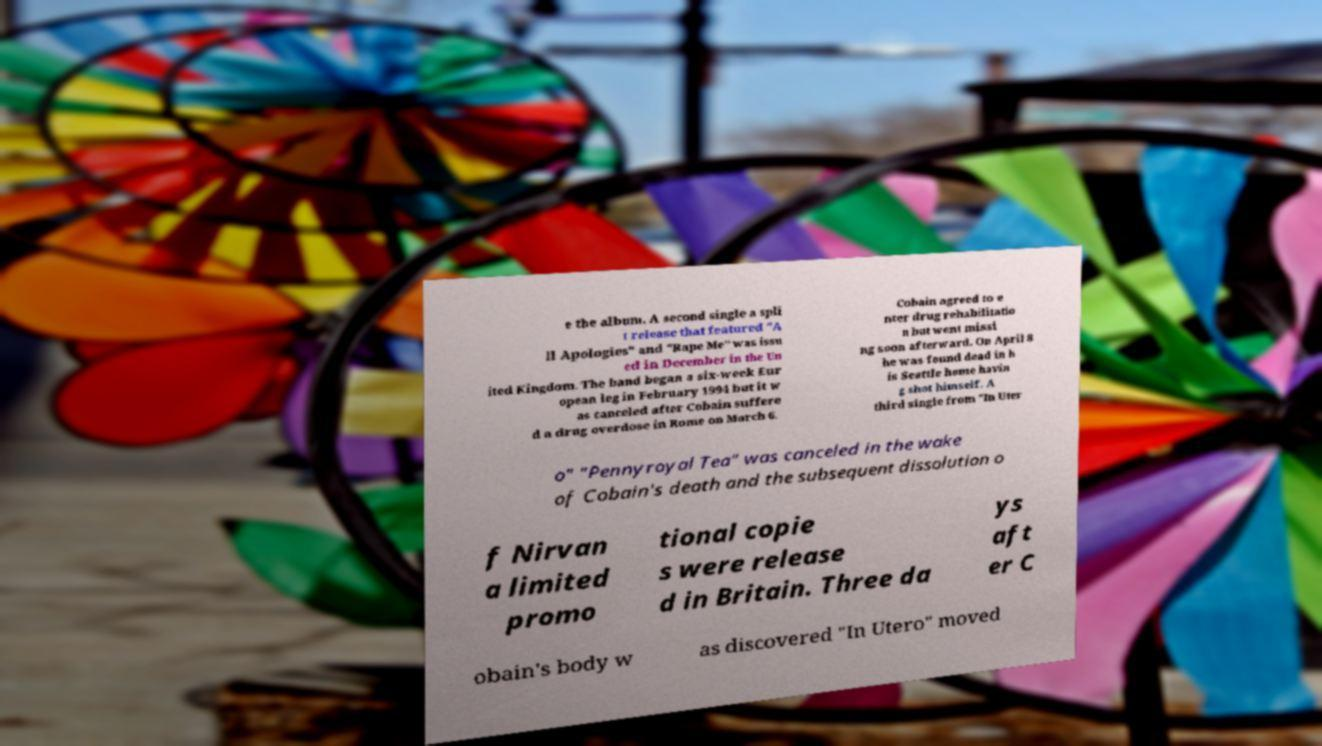I need the written content from this picture converted into text. Can you do that? e the album. A second single a spli t release that featured "A ll Apologies" and "Rape Me" was issu ed in December in the Un ited Kingdom. The band began a six-week Eur opean leg in February 1994 but it w as canceled after Cobain suffere d a drug overdose in Rome on March 6. Cobain agreed to e nter drug rehabilitatio n but went missi ng soon afterward. On April 8 he was found dead in h is Seattle home havin g shot himself. A third single from "In Uter o" "Pennyroyal Tea" was canceled in the wake of Cobain's death and the subsequent dissolution o f Nirvan a limited promo tional copie s were release d in Britain. Three da ys aft er C obain's body w as discovered "In Utero" moved 